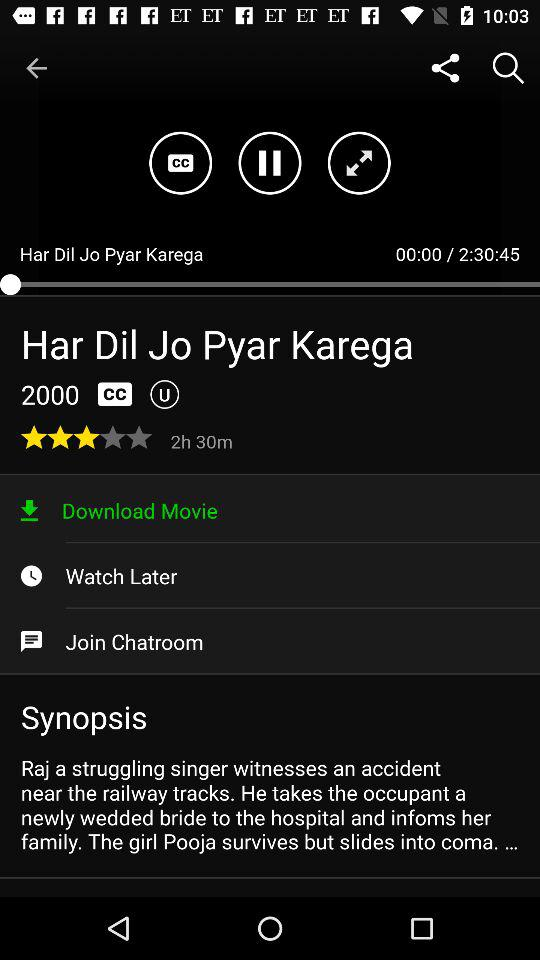What is the duration of the movie? The duration of the movie is 2 hours, 30 minutes and 45 seconds. 